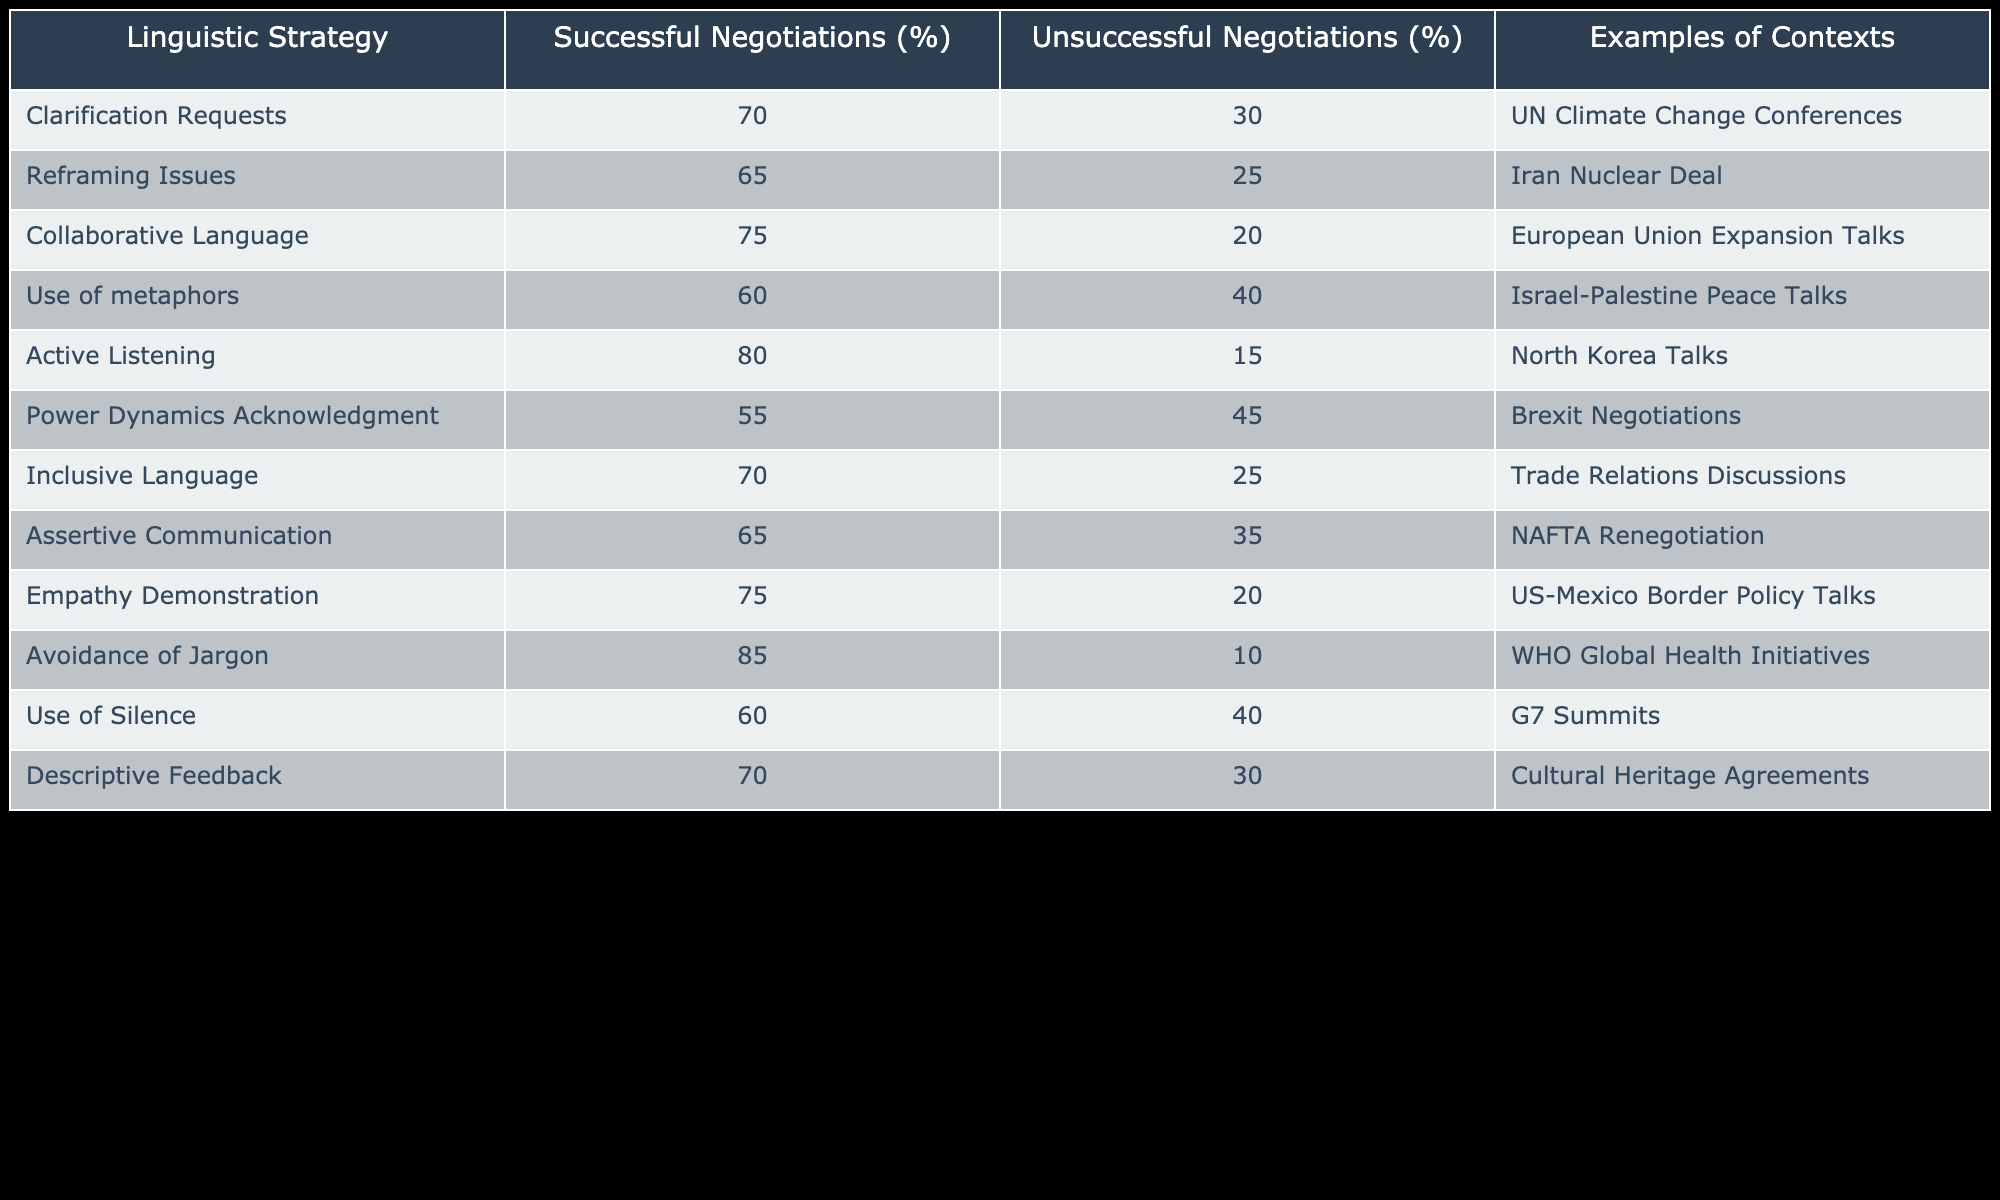What percentage of successful negotiations involved active listening? The table shows that active listening is employed in 80% of successful negotiations.
Answer: 80 Which linguistic strategy had the highest success rate? By examining the percentages in the 'Successful Negotiations (%)' column, we see that the highest percentage is 85 for avoidance of jargon.
Answer: 85 What is the difference in the successful negotiation percentage between collaborative language and assertive communication? Collaborative language has a success rate of 75%, while assertive communication has a success rate of 65%. The difference is calculated as 75 - 65 = 10.
Answer: 10 Is it true that the use of silence is more effective in successful negotiations than in unsuccessful ones? In the table, the successful negotiation percentage for use of silence is 60%, while for unsuccessful negotiations it is 40%. This means it is indeed more effective.
Answer: Yes What is the average percentage of successful negotiations for the strategies that involve empathy or collaboration? The two relevant strategies are empathy demonstration (75%) and collaborative language (75%). The average is calculated as (75 + 75) / 2 = 75.
Answer: 75 What percentage of unsuccessful negotiations utilized clarity requests and inclusive language? Clarification requests in unsuccessful negotiations are at 30%, and inclusive language is at 25%. Adding these gives a total of 30 + 25 = 55%.
Answer: 55 How many strategies had a success rate of 70% or above among successful negotiations? Looking at the successful negotiation percentages, there are five strategies with at least 70%: clarification requests (70%), collaborative language (75%), empathy demonstration (75%), inclusion language (70%), and avoidance of jargon (85%). So, there are 5 strategies in total.
Answer: 5 Is there a strategy that is more effective in successful negotiations than in unsuccessful negotiations, based on the collaboration and empathy criteria? Yes, both strategies show higher percentages for successful negotiations: collaborative language at 75% and empathy demonstration at 75% compared to 20% for both in unsuccessful negotiations, confirming their effectiveness.
Answer: Yes What is the total percentage of successful negotiations from the strategies that employ metaphors and power dynamics acknowledgment? The percentages for successful negotiations are 60% for the use of metaphors and 55% for the acknowledgment of power dynamics. The total is calculated as 60 + 55 = 115%.
Answer: 115 